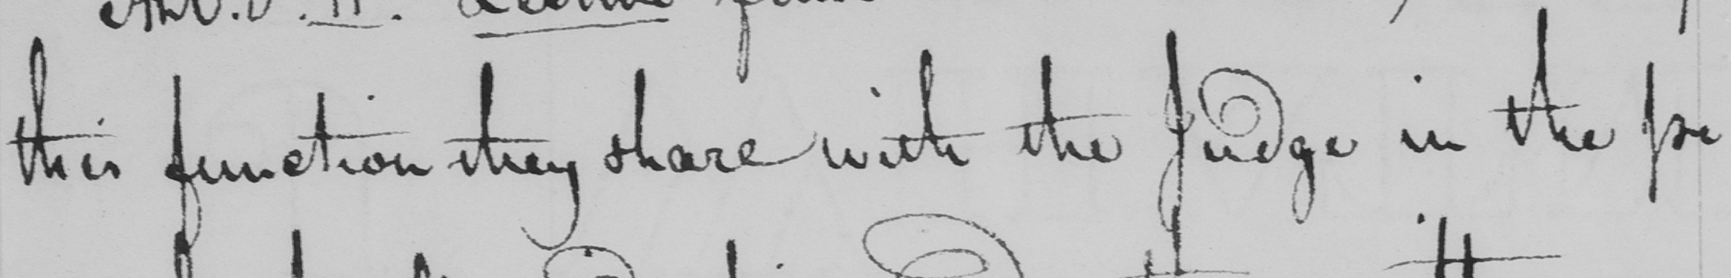What text is written in this handwritten line? this function they share with the Judge in the pe 